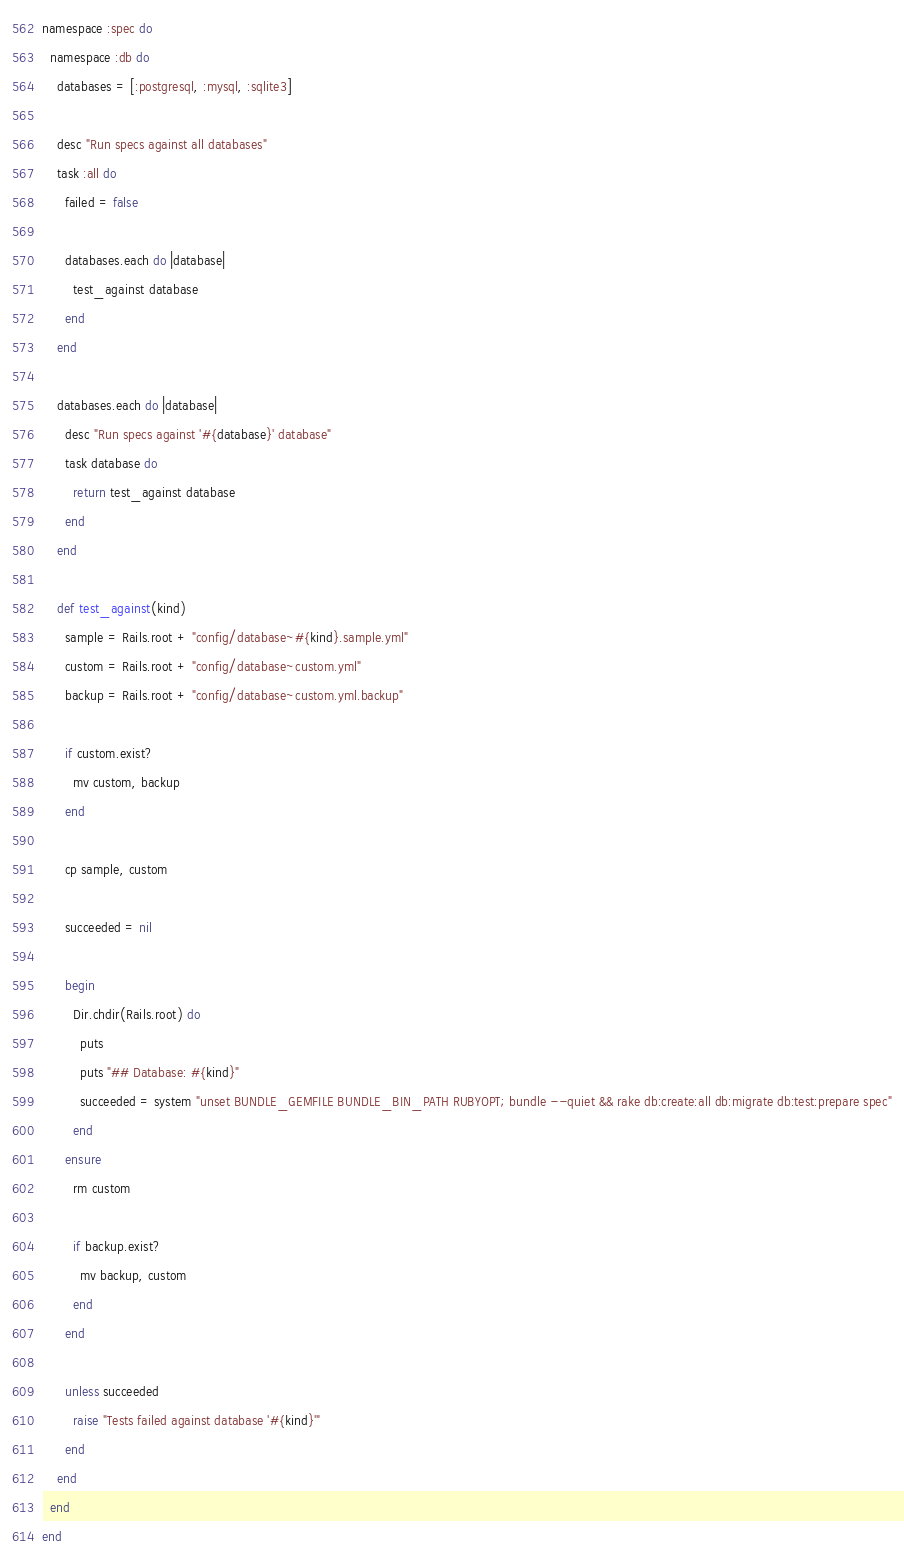Convert code to text. <code><loc_0><loc_0><loc_500><loc_500><_Ruby_>namespace :spec do
  namespace :db do
    databases = [:postgresql, :mysql, :sqlite3]

    desc "Run specs against all databases"
    task :all do
      failed = false

      databases.each do |database|
        test_against database
      end
    end

    databases.each do |database|
      desc "Run specs against '#{database}' database"
      task database do
        return test_against database
      end
    end

    def test_against(kind)
      sample = Rails.root + "config/database~#{kind}.sample.yml"
      custom = Rails.root + "config/database~custom.yml"
      backup = Rails.root + "config/database~custom.yml.backup"

      if custom.exist?
        mv custom, backup
      end

      cp sample, custom

      succeeded = nil

      begin
        Dir.chdir(Rails.root) do
          puts
          puts "## Database: #{kind}"
          succeeded = system "unset BUNDLE_GEMFILE BUNDLE_BIN_PATH RUBYOPT; bundle --quiet && rake db:create:all db:migrate db:test:prepare spec"
        end
      ensure
        rm custom

        if backup.exist?
          mv backup, custom
        end
      end

      unless succeeded
        raise "Tests failed against database '#{kind}'"
      end
    end
  end
end
</code> 